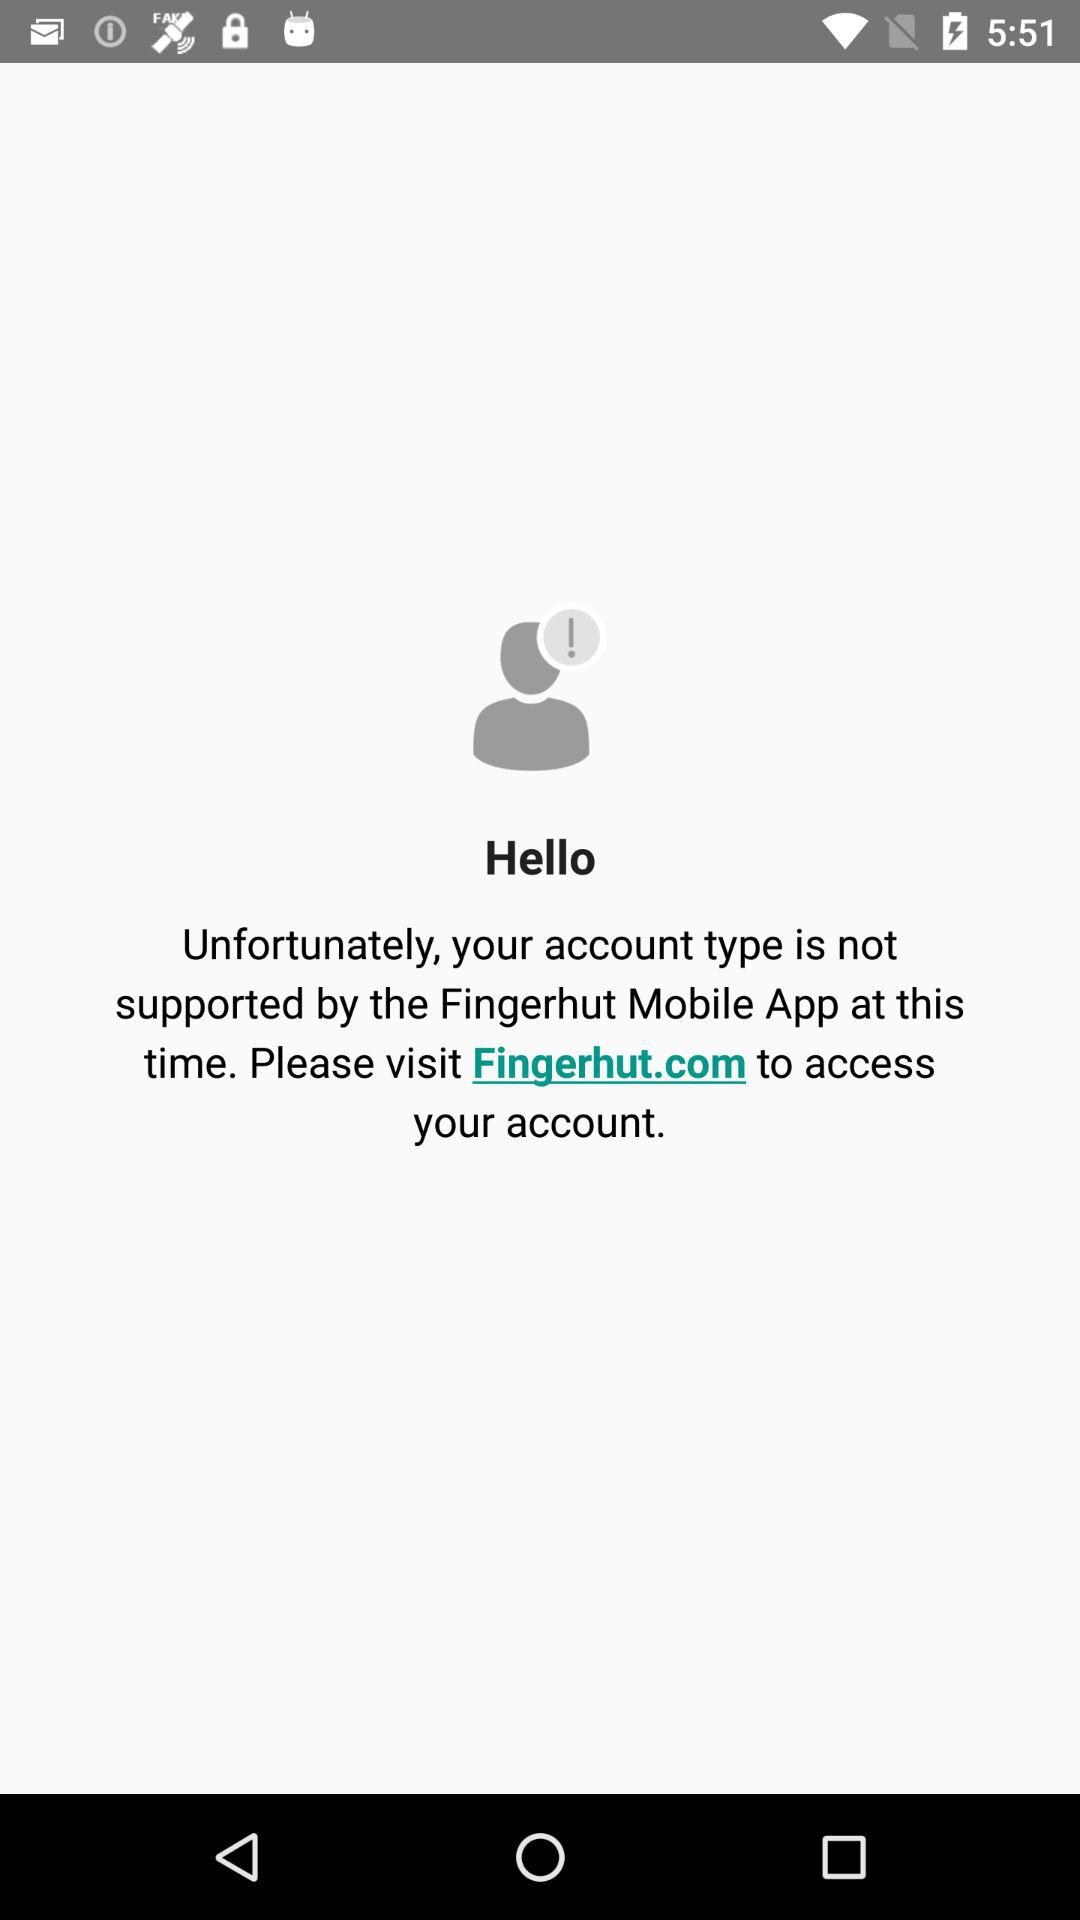What is the application name? The application name is "Fingerhut Mobile". 